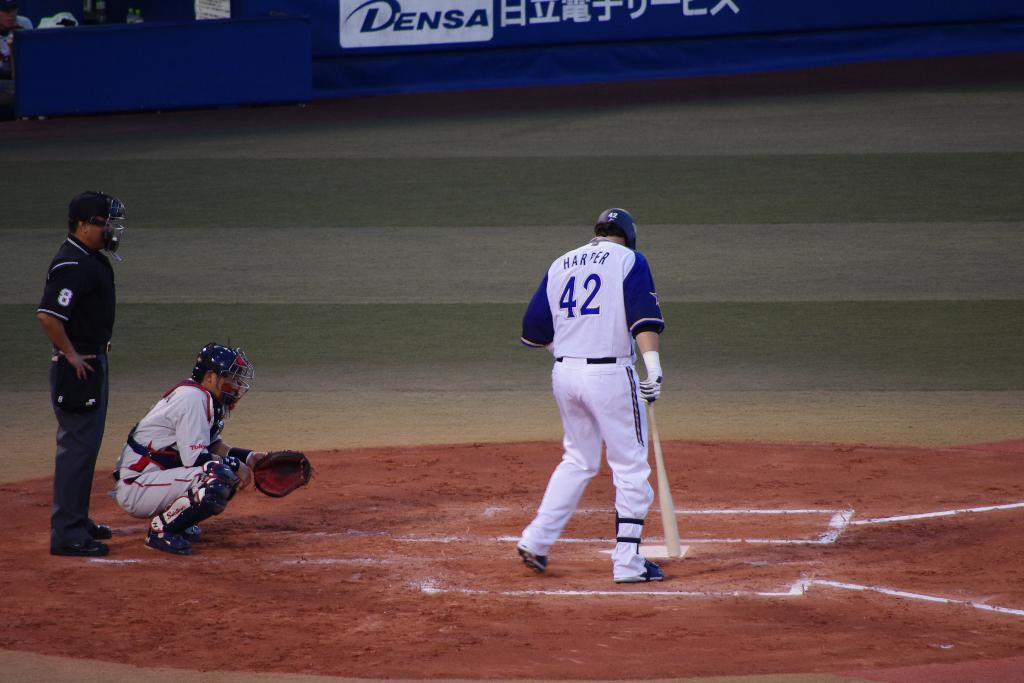<image>
Summarize the visual content of the image. a baseball player in 42 jersey at bat during a game 